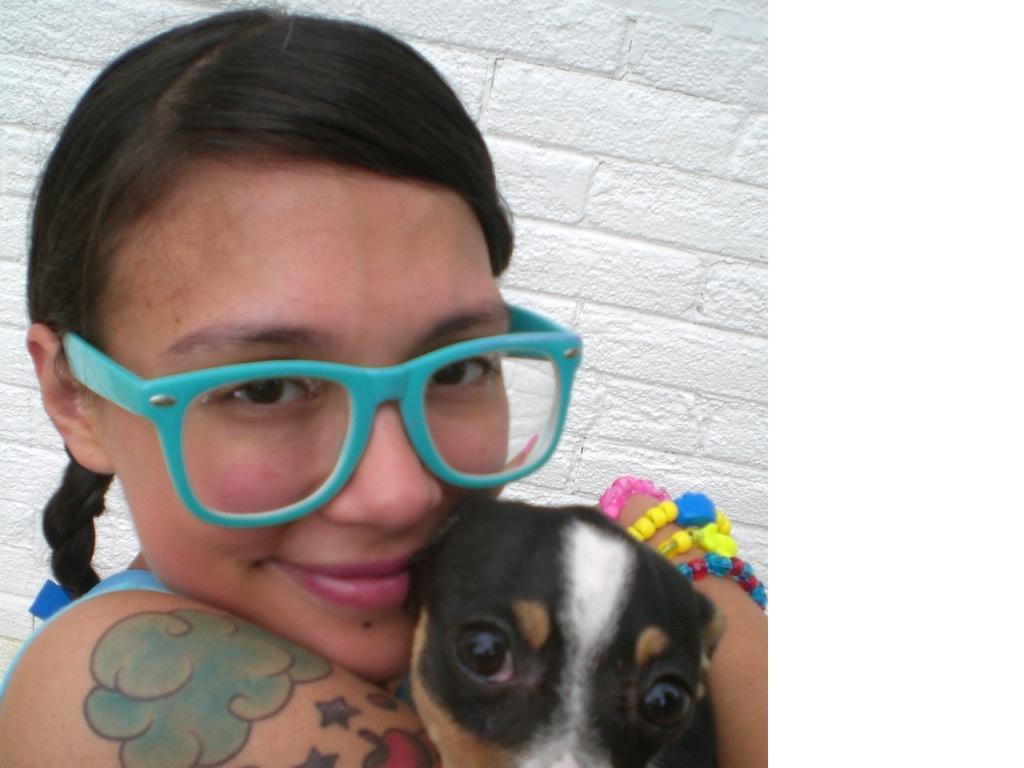Please provide a concise description of this image. This image consists of a girl holding a dog. She is wearing the specs. In the background, we can see a wall in white color. 